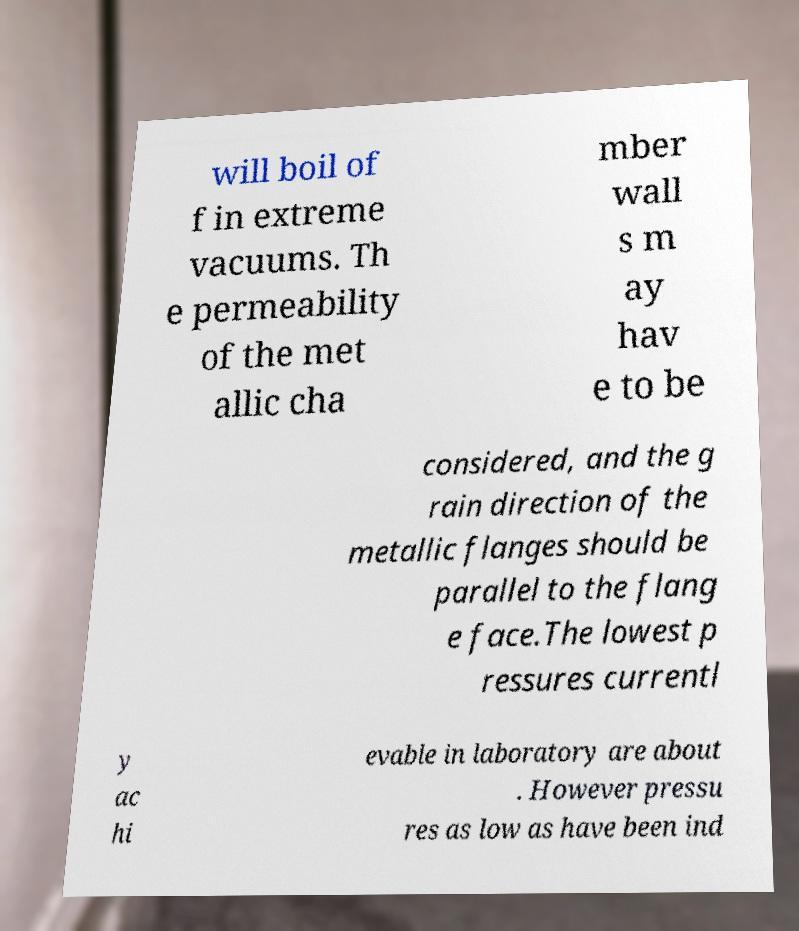I need the written content from this picture converted into text. Can you do that? will boil of f in extreme vacuums. Th e permeability of the met allic cha mber wall s m ay hav e to be considered, and the g rain direction of the metallic flanges should be parallel to the flang e face.The lowest p ressures currentl y ac hi evable in laboratory are about . However pressu res as low as have been ind 